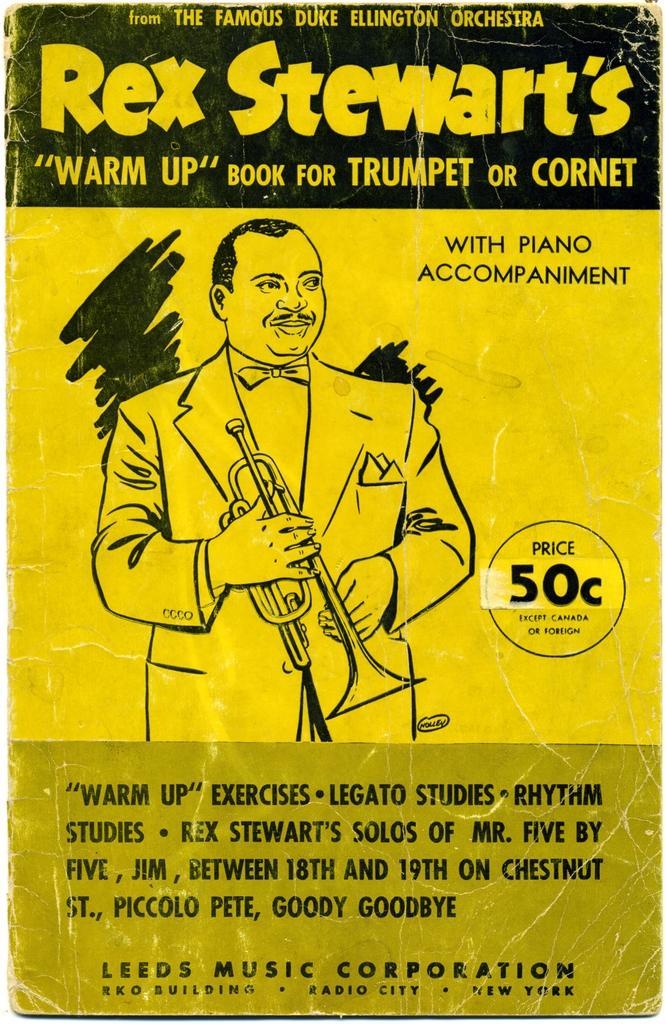Can you describe this image briefly? In this image I can see a yellow color thing and on it I can see depiction of a man holding a musical instrument. I can also see something is written on the top, in the centre and on the bottom side of this image. 